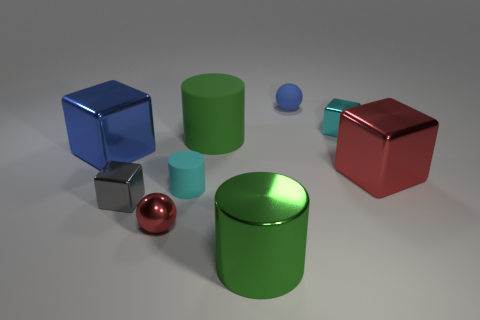Subtract all balls. How many objects are left? 7 Add 1 big purple matte objects. How many big purple matte objects exist? 1 Subtract 0 purple cubes. How many objects are left? 9 Subtract all red rubber objects. Subtract all big red objects. How many objects are left? 8 Add 6 shiny blocks. How many shiny blocks are left? 10 